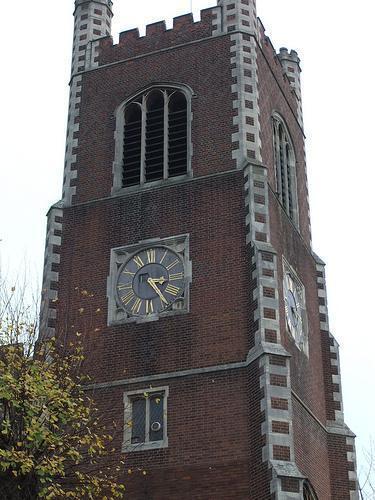How many clocks are on the right side of the building?
Give a very brief answer. 1. 